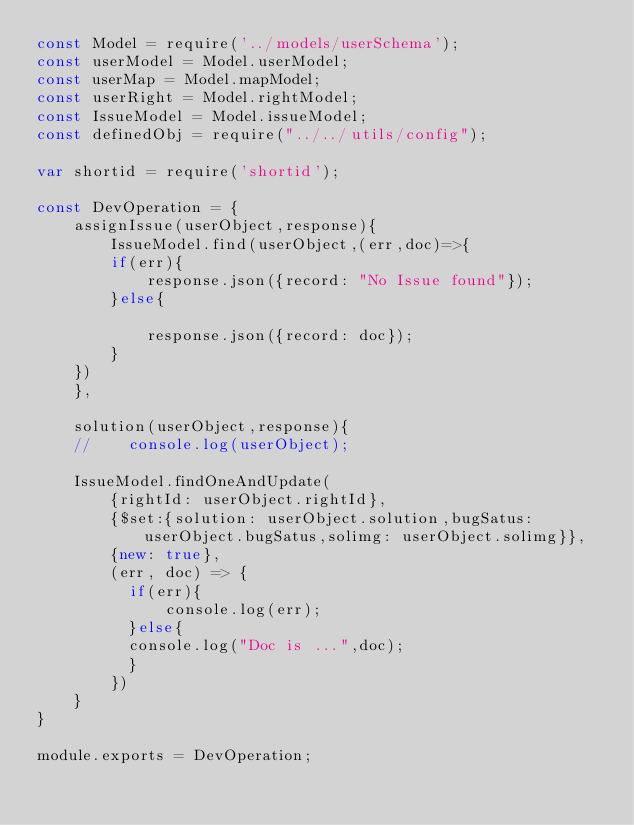Convert code to text. <code><loc_0><loc_0><loc_500><loc_500><_JavaScript_>const Model = require('../models/userSchema');
const userModel = Model.userModel;
const userMap = Model.mapModel;
const userRight = Model.rightModel;
const IssueModel = Model.issueModel;
const definedObj = require("../../utils/config");

var shortid = require('shortid');

const DevOperation = {
    assignIssue(userObject,response){
        IssueModel.find(userObject,(err,doc)=>{
        if(err){
            response.json({record: "No Issue found"});
        }else{

            response.json({record: doc});
        }
    })
    },

    solution(userObject,response){
    //    console.log(userObject);

    IssueModel.findOneAndUpdate(
        {rightId: userObject.rightId},
        {$set:{solution: userObject.solution,bugSatus: userObject.bugSatus,solimg: userObject.solimg}}, 
        {new: true}, 
        (err, doc) => {
          if(err){
              console.log(err);
          }else{
          console.log("Doc is ...",doc);
          }
        })
    }
}

module.exports = DevOperation;</code> 